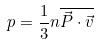<formula> <loc_0><loc_0><loc_500><loc_500>p = \frac { 1 } { 3 } n \overline { \vec { P } \cdot \vec { v } }</formula> 